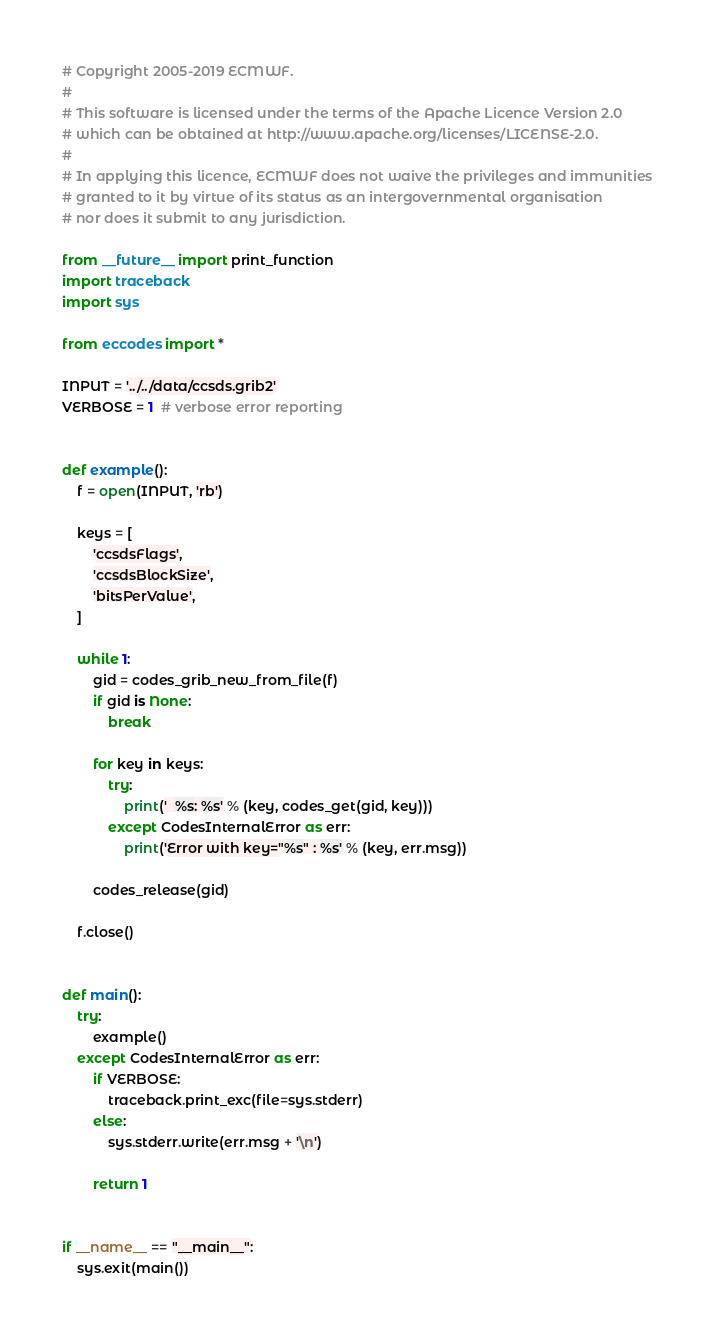Convert code to text. <code><loc_0><loc_0><loc_500><loc_500><_Python_># Copyright 2005-2019 ECMWF.
#
# This software is licensed under the terms of the Apache Licence Version 2.0
# which can be obtained at http://www.apache.org/licenses/LICENSE-2.0.
#
# In applying this licence, ECMWF does not waive the privileges and immunities
# granted to it by virtue of its status as an intergovernmental organisation
# nor does it submit to any jurisdiction.

from __future__ import print_function
import traceback
import sys

from eccodes import *

INPUT = '../../data/ccsds.grib2'
VERBOSE = 1  # verbose error reporting


def example():
    f = open(INPUT, 'rb')

    keys = [
        'ccsdsFlags',
        'ccsdsBlockSize',
        'bitsPerValue',
    ]

    while 1:
        gid = codes_grib_new_from_file(f)
        if gid is None:
            break

        for key in keys:
            try:
                print('  %s: %s' % (key, codes_get(gid, key)))
            except CodesInternalError as err:
                print('Error with key="%s" : %s' % (key, err.msg))

        codes_release(gid)

    f.close()


def main():
    try:
        example()
    except CodesInternalError as err:
        if VERBOSE:
            traceback.print_exc(file=sys.stderr)
        else:
            sys.stderr.write(err.msg + '\n')

        return 1


if __name__ == "__main__":
    sys.exit(main())
</code> 